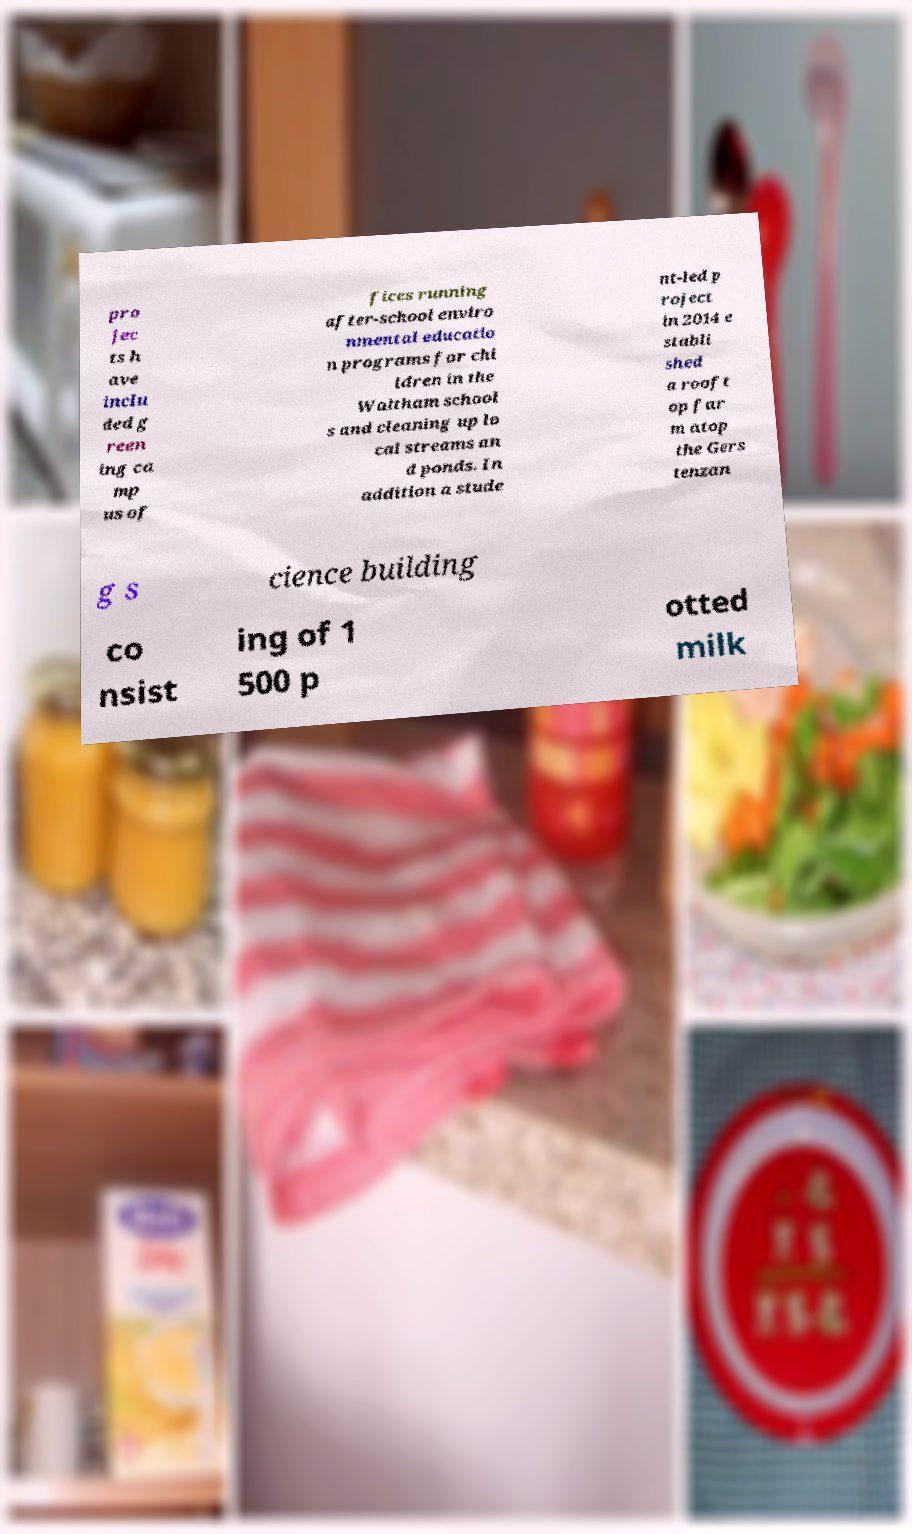For documentation purposes, I need the text within this image transcribed. Could you provide that? pro jec ts h ave inclu ded g reen ing ca mp us of fices running after-school enviro nmental educatio n programs for chi ldren in the Waltham school s and cleaning up lo cal streams an d ponds. In addition a stude nt-led p roject in 2014 e stabli shed a rooft op far m atop the Gers tenzan g s cience building co nsist ing of 1 500 p otted milk 